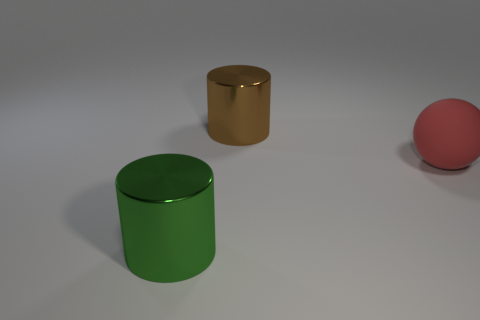Subtract 0 purple blocks. How many objects are left? 3 Subtract all spheres. How many objects are left? 2 Subtract 1 cylinders. How many cylinders are left? 1 Subtract all gray spheres. Subtract all gray cubes. How many spheres are left? 1 Subtract all blue cubes. How many green cylinders are left? 1 Subtract all green things. Subtract all big red metallic blocks. How many objects are left? 2 Add 3 red things. How many red things are left? 4 Add 1 blue metallic cylinders. How many blue metallic cylinders exist? 1 Add 3 red spheres. How many objects exist? 6 Subtract all brown cylinders. How many cylinders are left? 1 